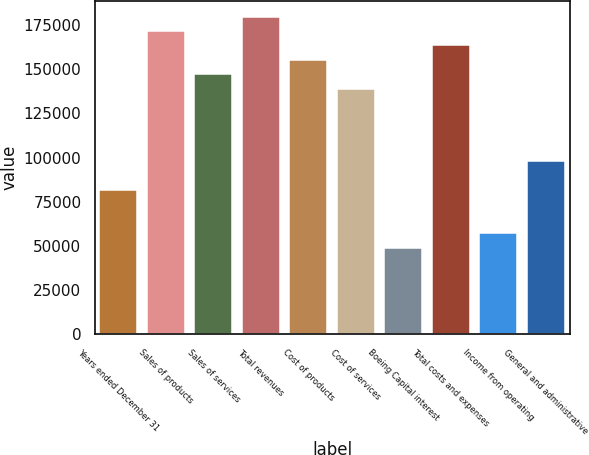<chart> <loc_0><loc_0><loc_500><loc_500><bar_chart><fcel>Years ended December 31<fcel>Sales of products<fcel>Sales of services<fcel>Total revenues<fcel>Cost of products<fcel>Cost of services<fcel>Boeing Capital interest<fcel>Total costs and expenses<fcel>Income from operating<fcel>General and administrative<nl><fcel>81698<fcel>171561<fcel>147053<fcel>179731<fcel>155223<fcel>138884<fcel>49020.4<fcel>163392<fcel>57189.8<fcel>98036.8<nl></chart> 